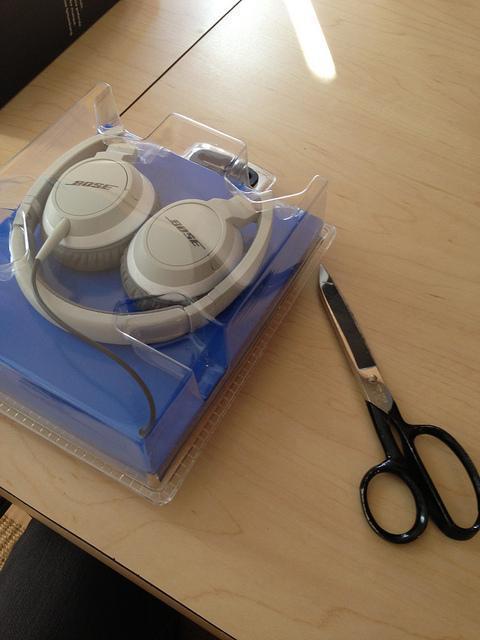How many scissors are in the photo?
Give a very brief answer. 1. 